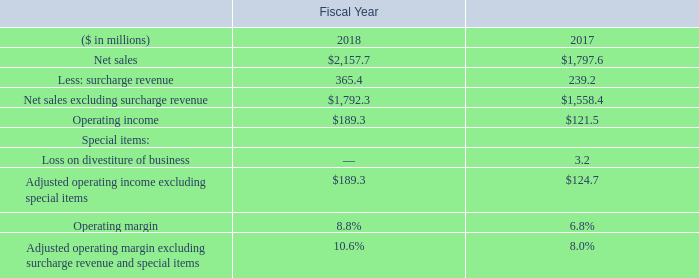Operating Income
Our operating income in fiscal year 2018 increased to $189.3 million, or 8.8 percent of net sales as compared with $121.5 million, or 6.8 percent in net sales in fiscal year 2017. Excluding surcharge revenue and special items, adjusted operating margin was 10.6 percent for the fiscal year 2018 and 8.0 percent for fiscal year 2017. The increase in the operating margin reflects the stronger demand and improved product mix coupled with operating cost improvements partially offset by higher variable compensation expense compared to fiscal year 2017.
Operating income has been impacted by special items. The following presents our operating income and operating margin, in each case excluding the impact of surcharge on net sales and the loss on divestiture of business. We present and discuss these financial measures because management believes removing the impact of these items provides a more consistent and meaningful basis for comparing results of operations from period to period. See the section “Non-GAAP Financial Measures” below for further discussion of these financial measures.
What was operating income in 2018? $189.3 million. What was operating income in 2017 as a percentage of net sales? 6.8 percent. In which years was operating income calculated? 2018, 2017. In which year was the operating margin larger? 8.8%>6.8%
Answer: 2018. What was the change in operating income in 2018 from 2017?
Answer scale should be: million. 189.3-121.5
Answer: 67.8. What was the percentage change in operating income in 2018 from 2017?
Answer scale should be: percent. (189.3-121.5)/121.5
Answer: 55.8. 